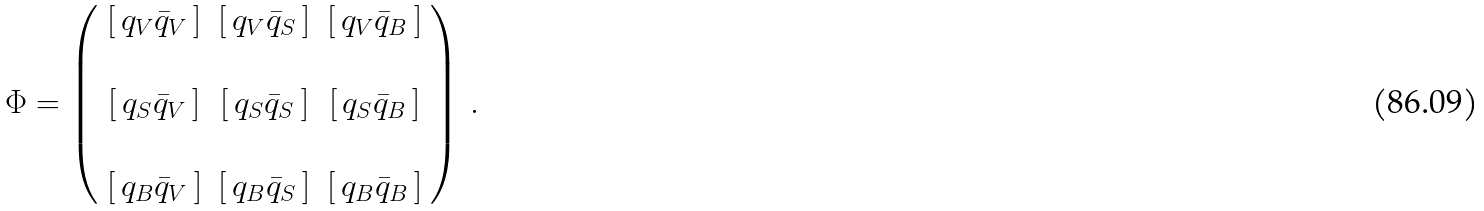Convert formula to latex. <formula><loc_0><loc_0><loc_500><loc_500>\Phi = \left ( \begin{array} { c c c } \left [ \, q _ { V } \bar { q } _ { V } \, \right ] & \left [ \, q _ { V } \bar { q } _ { S } \, \right ] & \left [ \, q _ { V } \bar { q } _ { B } \, \right ] \\ \\ \left [ \, q _ { S } \bar { q } _ { V } \, \right ] & \left [ \, q _ { S } \bar { q } _ { S } \, \right ] & \left [ \, q _ { S } \bar { q } _ { B } \, \right ] \\ \\ \left [ \, q _ { B } \bar { q } _ { V } \, \right ] & \left [ \, q _ { B } \bar { q } _ { S } \, \right ] & \left [ \, q _ { B } \bar { q } _ { B } \, \right ] \end{array} \right ) \, .</formula> 